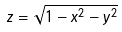Convert formula to latex. <formula><loc_0><loc_0><loc_500><loc_500>z = \sqrt { 1 - x ^ { 2 } - y ^ { 2 } }</formula> 